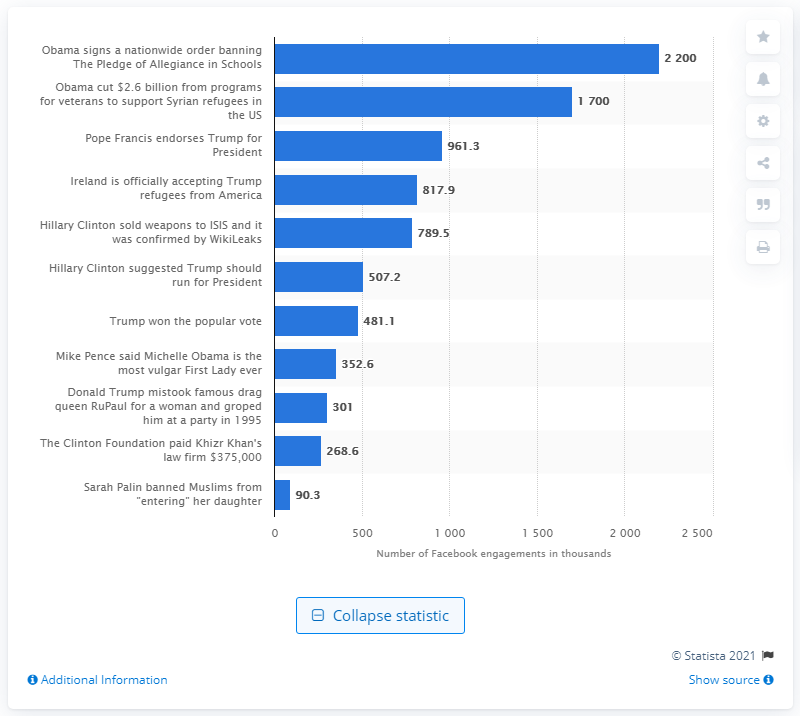Can you tell me about any trends or patterns observed in the sharing of these fake news stories? Certainly, based on the image, the sharing of fake news stories on Facebook seems to have a political theme, often involving high-profile individuals in the context of U.S. politics. Stories making particularly bold or sensational claims tend to have higher shares, indicating a potential correlation between the audacity of the claim and its viral potential on social media. 